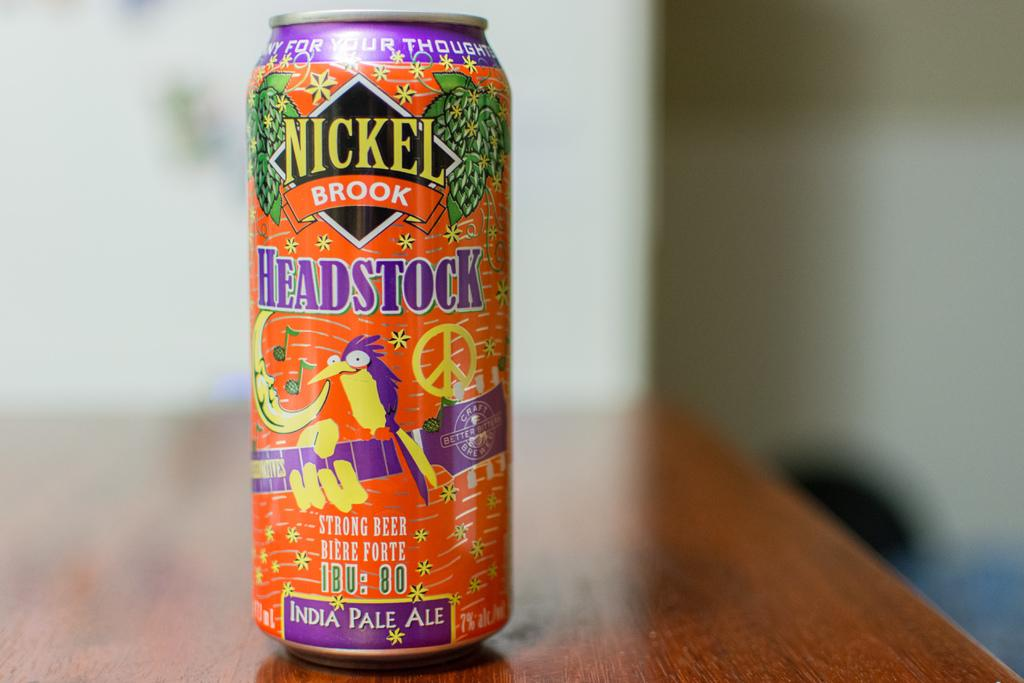<image>
Provide a brief description of the given image. The colourful tin with a parrot on the front contains India Pale Ale. 